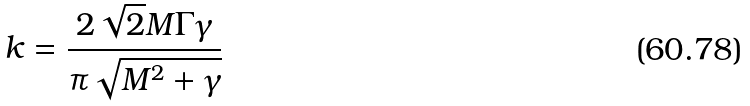Convert formula to latex. <formula><loc_0><loc_0><loc_500><loc_500>k = \frac { 2 \sqrt { 2 } M \Gamma \gamma } { \pi \sqrt { M ^ { 2 } + \gamma } }</formula> 